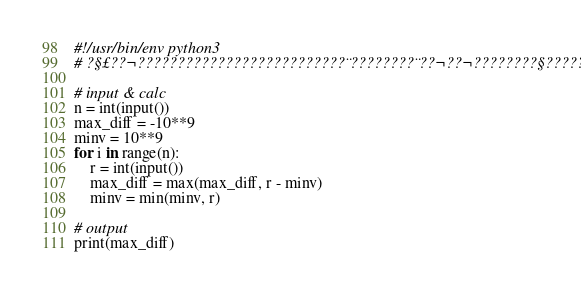Convert code to text. <code><loc_0><loc_0><loc_500><loc_500><_Python_>#!/usr/bin/env python3
# ?§£??¬??????????????????????????¨????????¨??¬??¬????????§??????

# input & calc
n = int(input())
max_diff = -10**9
minv = 10**9
for i in range(n):
    r = int(input())
    max_diff = max(max_diff, r - minv)
    minv = min(minv, r)

# output
print(max_diff)</code> 